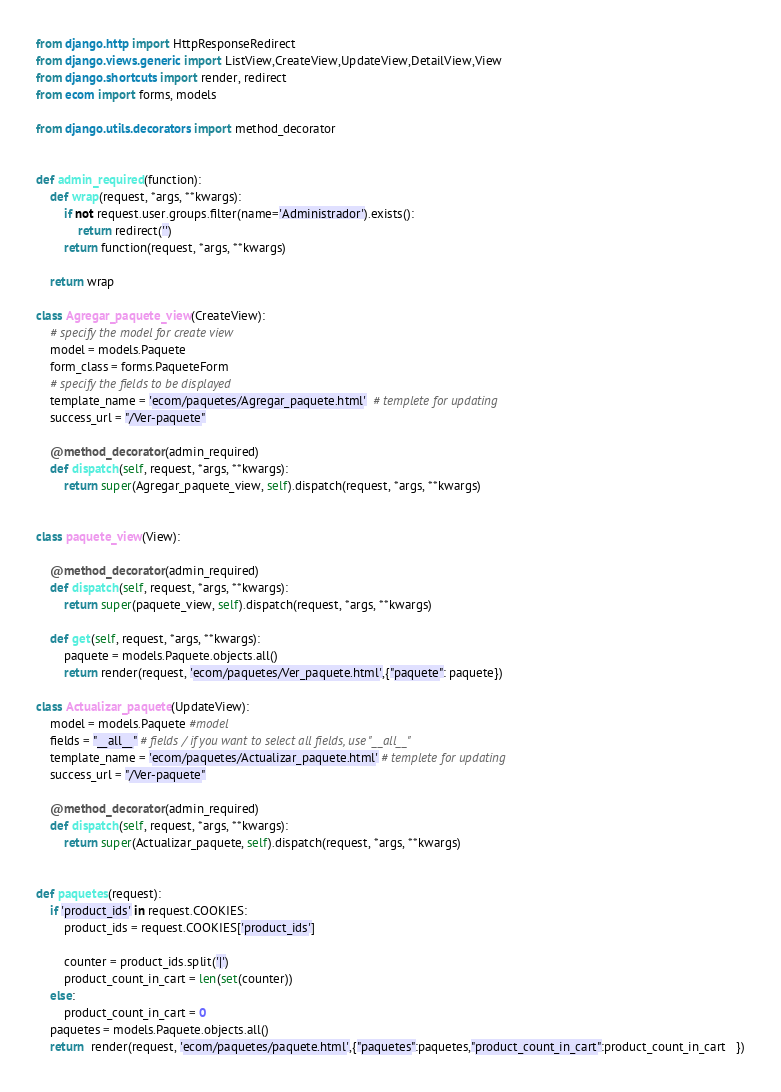Convert code to text. <code><loc_0><loc_0><loc_500><loc_500><_Python_>from django.http import HttpResponseRedirect
from django.views.generic import ListView,CreateView,UpdateView,DetailView,View
from django.shortcuts import render, redirect
from ecom import forms, models

from django.utils.decorators import method_decorator


def admin_required(function):
    def wrap(request, *args, **kwargs):
        if not request.user.groups.filter(name='Administrador').exists():
            return redirect('')
        return function(request, *args, **kwargs)

    return wrap

class Agregar_paquete_view(CreateView):
    # specify the model for create view
    model = models.Paquete
    form_class = forms.PaqueteForm
    # specify the fields to be displayed
    template_name = 'ecom/paquetes/Agregar_paquete.html'  # templete for updating
    success_url = "/Ver-paquete"

    @method_decorator(admin_required)
    def dispatch(self, request, *args, **kwargs):
        return super(Agregar_paquete_view, self).dispatch(request, *args, **kwargs)


class paquete_view(View):

    @method_decorator(admin_required)
    def dispatch(self, request, *args, **kwargs):
        return super(paquete_view, self).dispatch(request, *args, **kwargs)

    def get(self, request, *args, **kwargs):
        paquete = models.Paquete.objects.all()
        return render(request, 'ecom/paquetes/Ver_paquete.html',{"paquete": paquete})

class Actualizar_paquete(UpdateView):
    model = models.Paquete #model
    fields = "__all__" # fields / if you want to select all fields, use "__all__"
    template_name = 'ecom/paquetes/Actualizar_paquete.html' # templete for updating
    success_url = "/Ver-paquete"

    @method_decorator(admin_required)
    def dispatch(self, request, *args, **kwargs):
        return super(Actualizar_paquete, self).dispatch(request, *args, **kwargs)


def paquetes(request):
    if 'product_ids' in request.COOKIES:
        product_ids = request.COOKIES['product_ids']

        counter = product_ids.split('|')
        product_count_in_cart = len(set(counter))
    else:
        product_count_in_cart = 0
    paquetes = models.Paquete.objects.all()
    return  render(request, 'ecom/paquetes/paquete.html',{"paquetes":paquetes,"product_count_in_cart":product_count_in_cart   })</code> 